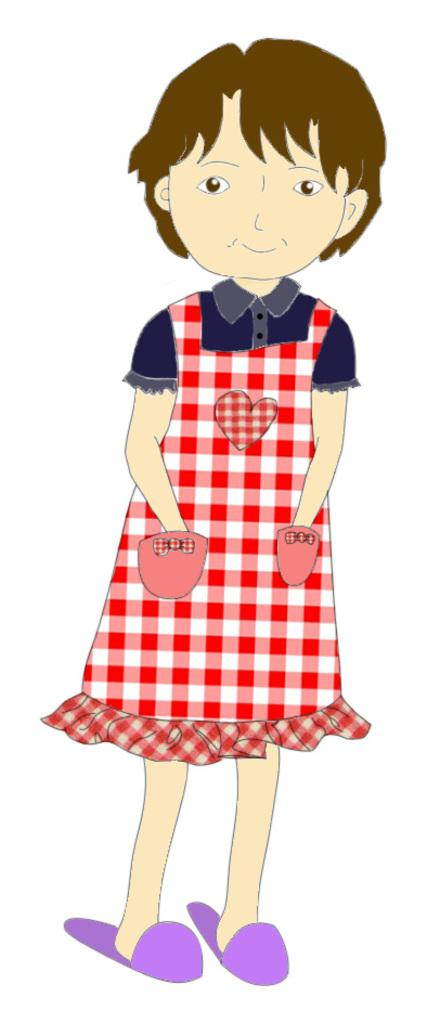What is the main subject of the image? There is an animation of a girl in the image. What type of receipt is the girl holding in the image? There is no receipt present in the image; it features an animation of a girl. What scientific theory is the girl discussing in the image? There is no indication in the image that the girl is discussing any scientific theory. 